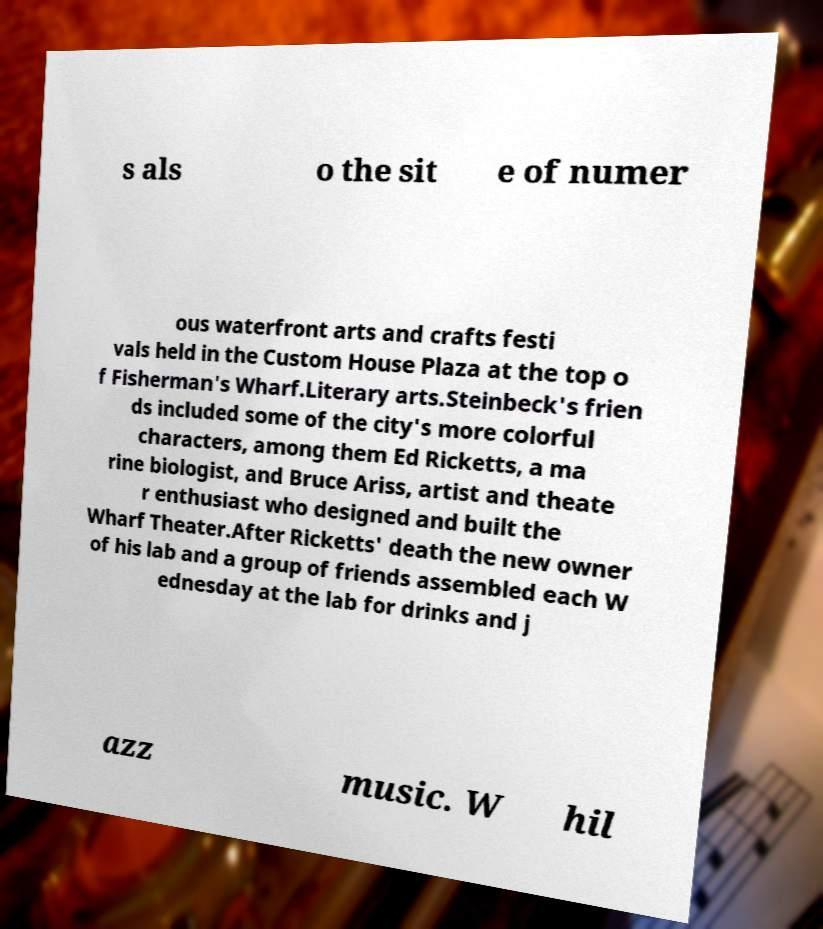Please identify and transcribe the text found in this image. s als o the sit e of numer ous waterfront arts and crafts festi vals held in the Custom House Plaza at the top o f Fisherman's Wharf.Literary arts.Steinbeck's frien ds included some of the city's more colorful characters, among them Ed Ricketts, a ma rine biologist, and Bruce Ariss, artist and theate r enthusiast who designed and built the Wharf Theater.After Ricketts' death the new owner of his lab and a group of friends assembled each W ednesday at the lab for drinks and j azz music. W hil 